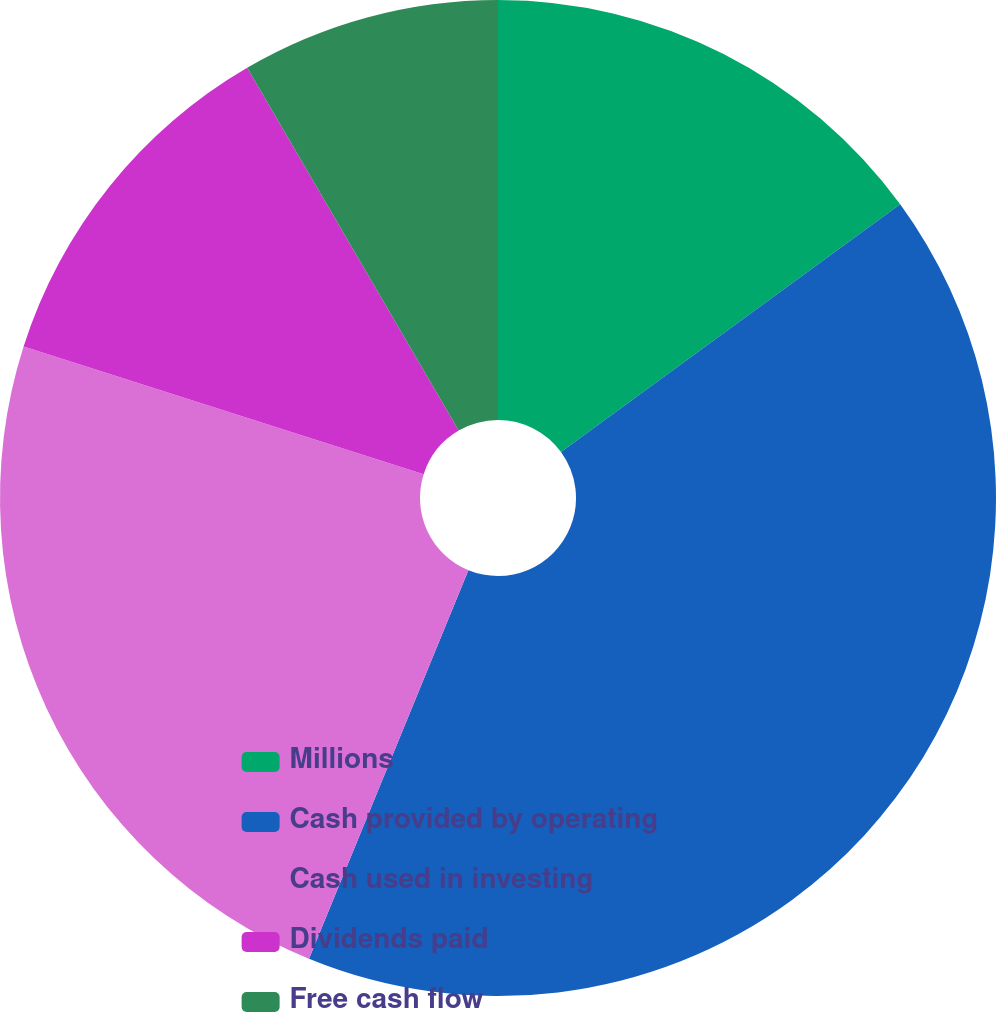<chart> <loc_0><loc_0><loc_500><loc_500><pie_chart><fcel>Millions<fcel>Cash provided by operating<fcel>Cash used in investing<fcel>Dividends paid<fcel>Free cash flow<nl><fcel>14.96%<fcel>41.23%<fcel>23.72%<fcel>11.68%<fcel>8.4%<nl></chart> 